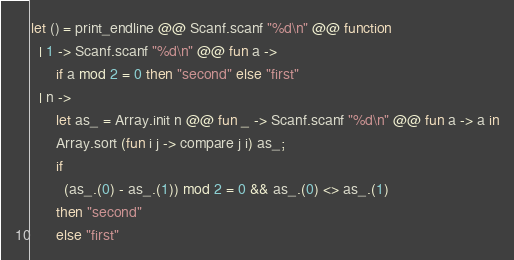Convert code to text. <code><loc_0><loc_0><loc_500><loc_500><_OCaml_>let () = print_endline @@ Scanf.scanf "%d\n" @@ function
  | 1 -> Scanf.scanf "%d\n" @@ fun a ->
      if a mod 2 = 0 then "second" else "first"
  | n ->
      let as_ = Array.init n @@ fun _ -> Scanf.scanf "%d\n" @@ fun a -> a in
      Array.sort (fun i j -> compare j i) as_;
      if
        (as_.(0) - as_.(1)) mod 2 = 0 && as_.(0) <> as_.(1)
      then "second"
      else "first"
</code> 